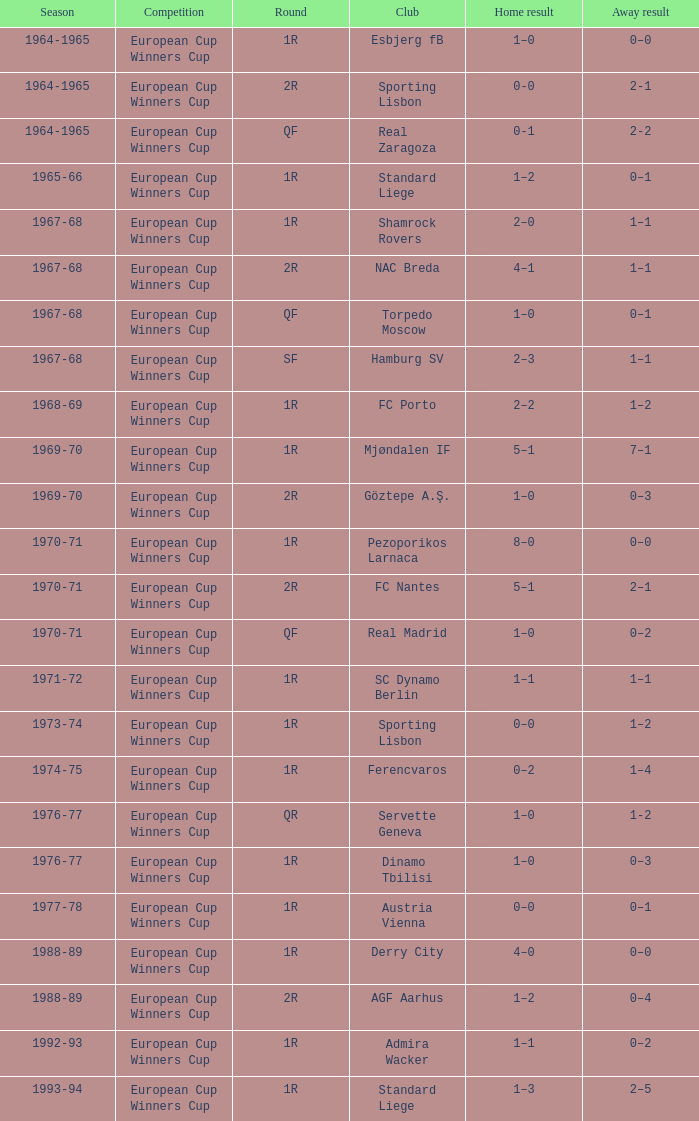Round of 2r, and a Home result of 0-0 has what season? 1964-1965. 